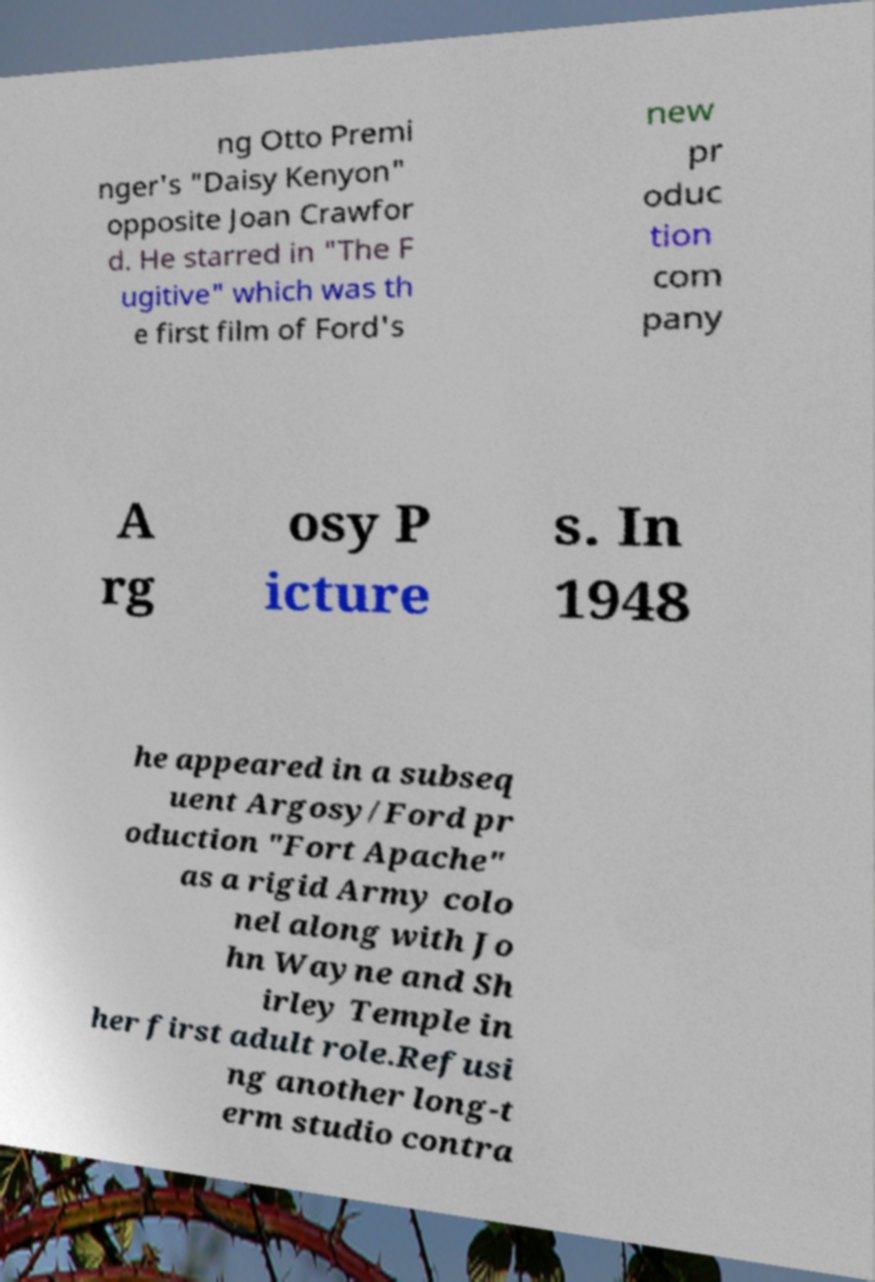Please read and relay the text visible in this image. What does it say? ng Otto Premi nger's "Daisy Kenyon" opposite Joan Crawfor d. He starred in "The F ugitive" which was th e first film of Ford's new pr oduc tion com pany A rg osy P icture s. In 1948 he appeared in a subseq uent Argosy/Ford pr oduction "Fort Apache" as a rigid Army colo nel along with Jo hn Wayne and Sh irley Temple in her first adult role.Refusi ng another long-t erm studio contra 